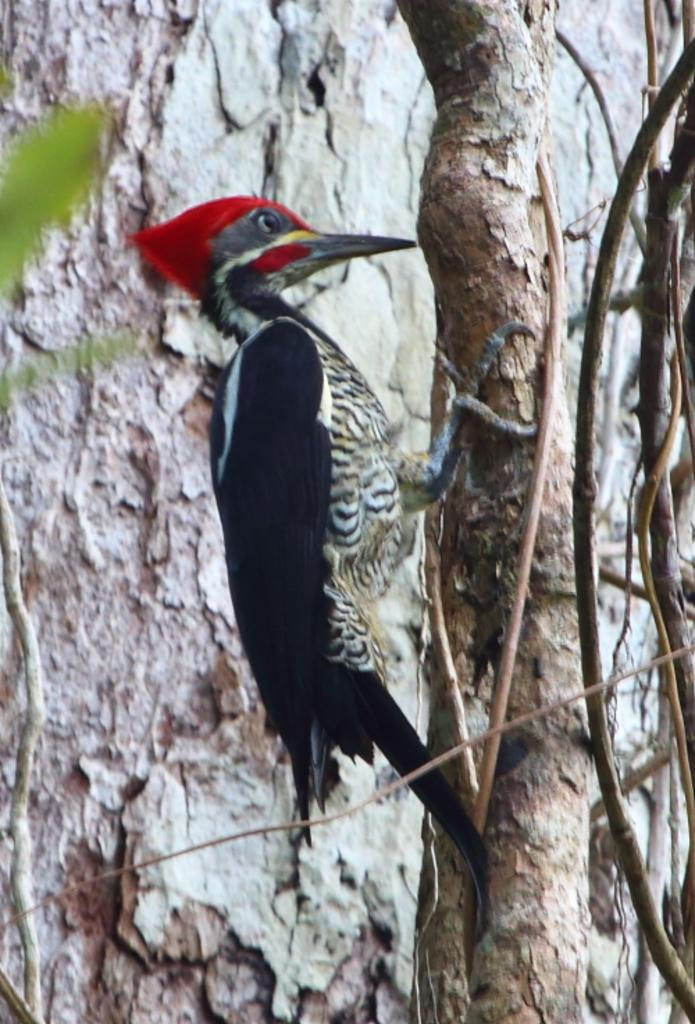What type of animal can be seen in the image? There is a bird in the image. Where is the bird located? The bird is on a tree. What part of the tree is visible behind the bird? The trunk of the tree is visible behind the bird. What type of vegetation is present on the tree? There are leaves on the left side of the tree. What type of credit card does the bird have in the image? There is no credit card present in the image; it features a bird on a tree. How many fingers does the bird have in the image? Birds do not have fingers; they have claws. However, there is no bird's claw visible in the image. 